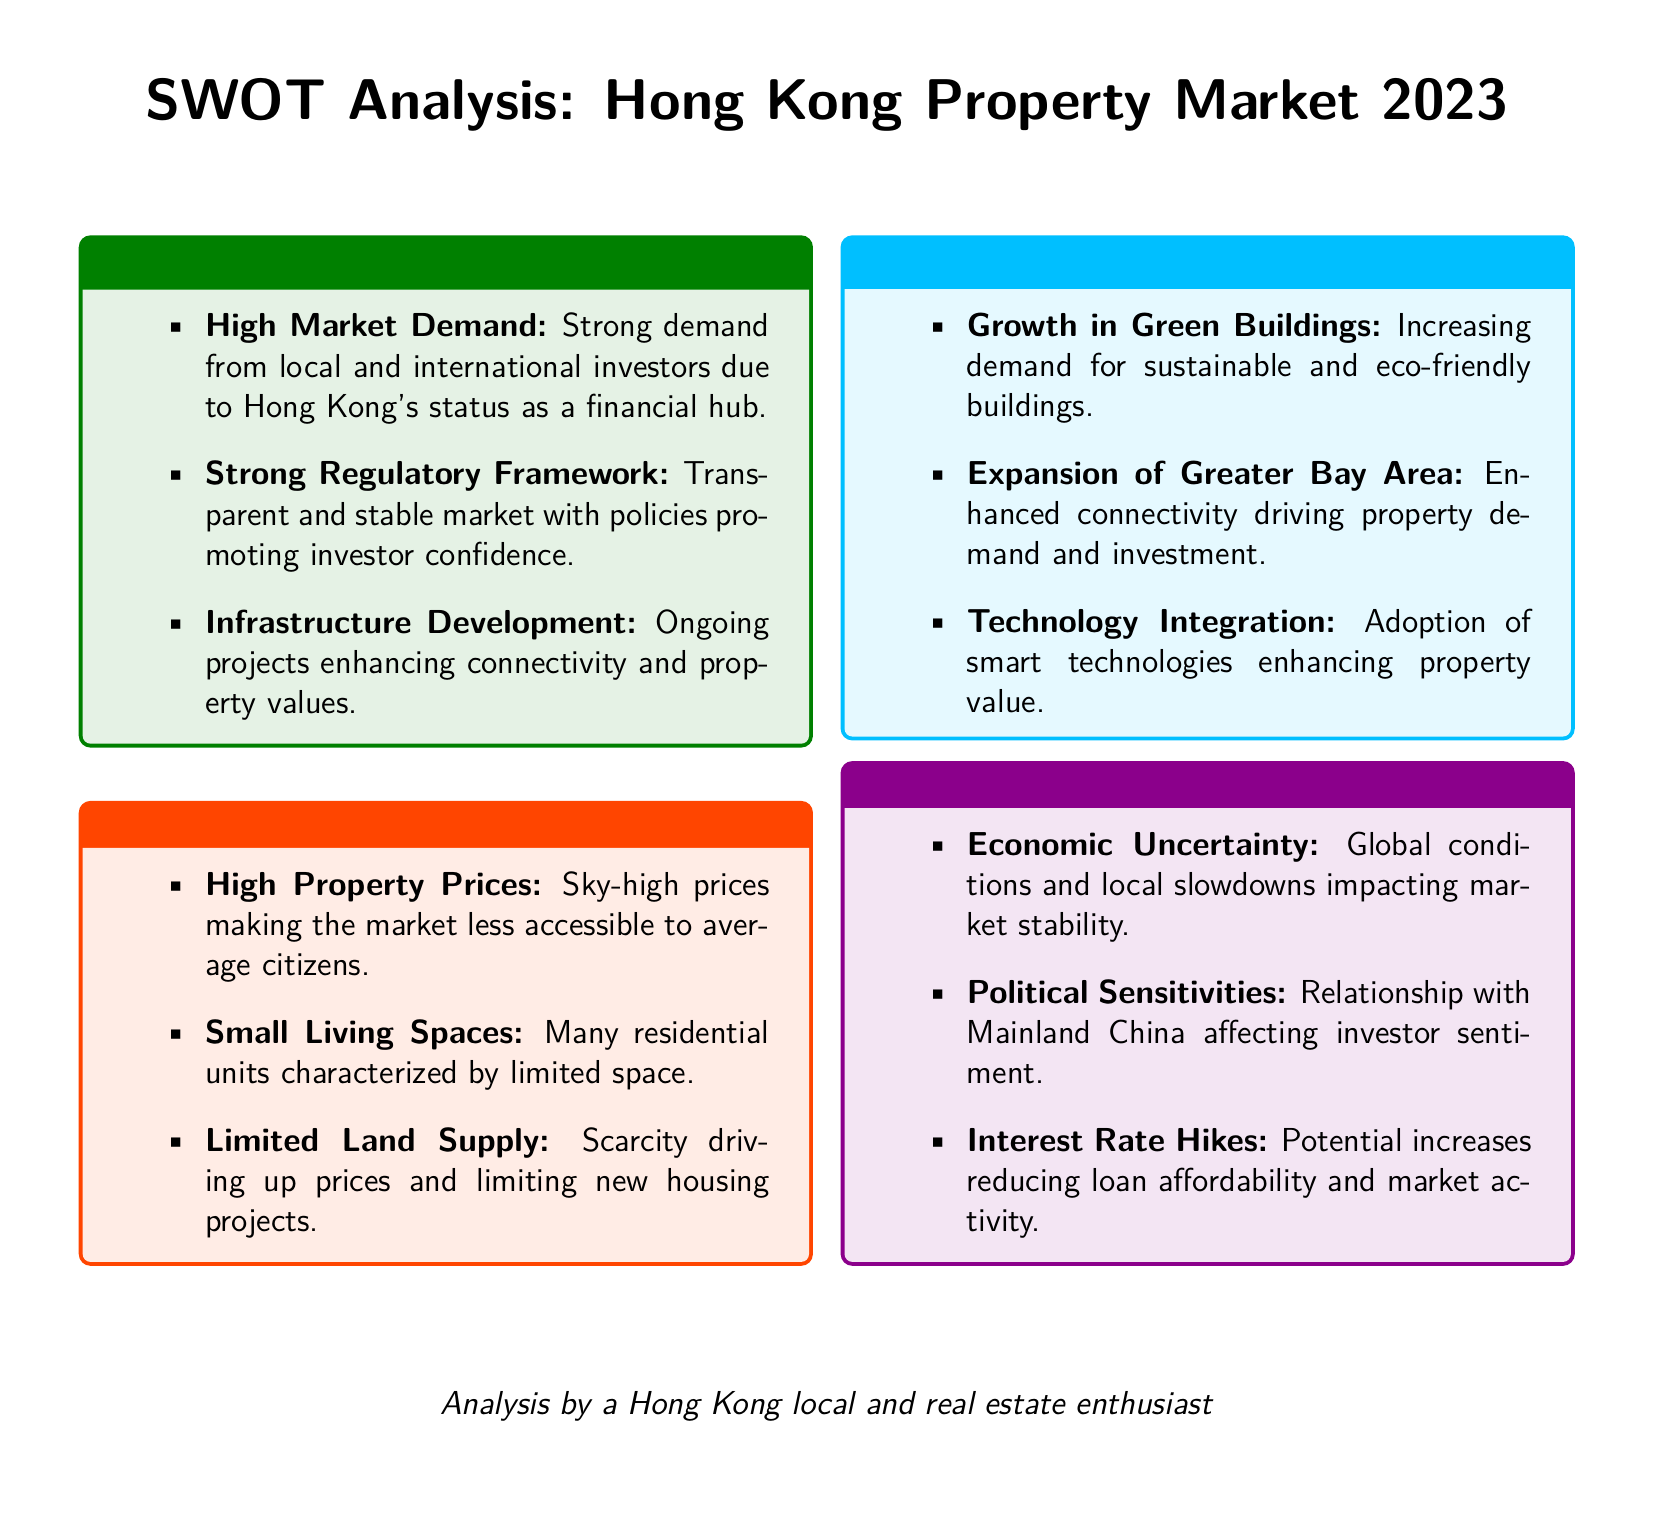What is a major strength of the Hong Kong property market? The document states that a major strength is the "High Market Demand" due to Hong Kong's status as a financial hub.
Answer: High Market Demand What factor contributes to the limited housing projects in Hong Kong? The document mentions "Limited Land Supply" as a driving factor for high prices and limited new housing projects.
Answer: Limited Land Supply What opportunity is arising from the Greater Bay Area? The document notes that "Expansion of Greater Bay Area" is enhancing connectivity, driving property demand and investment.
Answer: Expansion of Greater Bay Area What potential threat could affect loan affordability? According to the document, "Interest Rate Hikes" are mentioned as a potential threat that could reduce loan affordability.
Answer: Interest Rate Hikes What type of buildings is experiencing growth in demand? The document highlights an "increase in demand for sustainable and eco-friendly buildings" as a significant opportunity.
Answer: Green Buildings What weakness makes the market less accessible to citizens? The document indicates "High Property Prices" as a weakness that makes the market less accessible.
Answer: High Property Prices What does the SWOT analysis suggest about the market's regulatory environment? The document states the "Strong Regulatory Framework" as a strength, indicating a transparent and stable market.
Answer: Strong Regulatory Framework What is the implication of political sensitivities mentioned in the analysis? The document points out "Political Sensitivities" as a threat affecting investor sentiment.
Answer: Political Sensitivities 